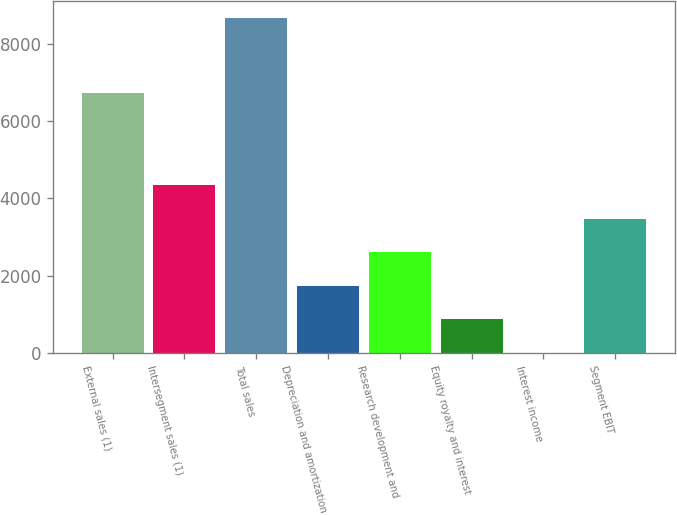<chart> <loc_0><loc_0><loc_500><loc_500><bar_chart><fcel>External sales (1)<fcel>Intersegment sales (1)<fcel>Total sales<fcel>Depreciation and amortization<fcel>Research development and<fcel>Equity royalty and interest<fcel>Interest income<fcel>Segment EBIT<nl><fcel>6733<fcel>4340.5<fcel>8670<fcel>1742.8<fcel>2608.7<fcel>876.9<fcel>11<fcel>3474.6<nl></chart> 